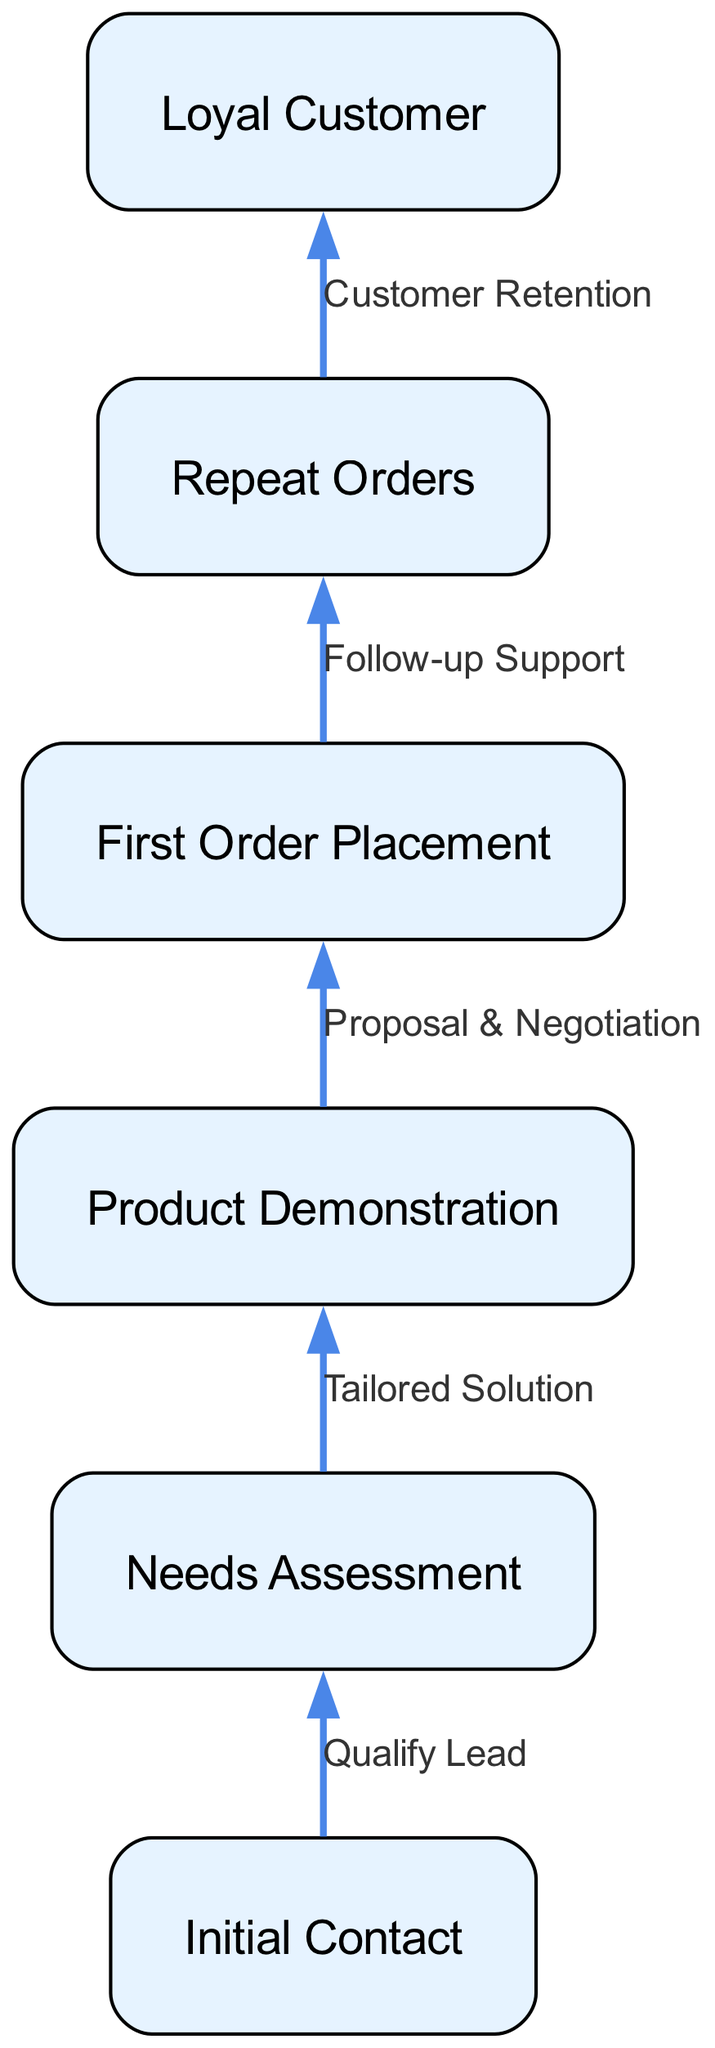What's the total number of nodes in the diagram? The diagram lists a set of nodes: "Loyal Customer," "Repeat Orders," "First Order Placement," "Product Demonstration," "Needs Assessment," and "Initial Contact." Counting these, we find there are six nodes in total.
Answer: 6 What is the last stage in the customer acquisition funnel? In the flow chart, the last stage represented as a node is "Loyal Customer." This is the endpoint of the customer acquisition process, indicating where a customer ideally wants to reach.
Answer: Loyal Customer What is the relationship between "First Order Placement" and "Repeat Orders"? The relationship is indicated by the edge connecting the two nodes. The text on this edge states "Follow-up Support," which describes the action that leads to the transition from "First Order Placement" to "Repeat Orders."
Answer: Follow-up Support Which stage comes after "Needs Assessment"? Following the "Needs Assessment" stage, the next node reached is "Product Demonstration." This indicates the process flow from assessing customer needs to demonstrating the product.
Answer: Product Demonstration How many edges are there in the diagram? The diagram includes connections (edges) that convey the relationships between the nodes. A review of the edges presents five connections in total.
Answer: 5 What action must occur before a "First Order Placement" can happen? According to the diagram, the action that must take place before reaching "First Order Placement" is "Product Demonstration." This step is crucial for proceeding to an actual order.
Answer: Product Demonstration What connects "Initial Contact" to "Needs Assessment"? The edge between "Initial Contact" and "Needs Assessment" is labeled with the text "Qualify Lead," signifying the essential action taken at this point in the funnel.
Answer: Qualify Lead Which node shows the beginning of the flow? The initial node in the flow chart labeled is "Initial Contact," which represents the starting point for engaging potential customers.
Answer: Initial Contact What follows immediately after "Repeat Orders"? The next stage after "Repeat Orders" is "Loyal Customer," indicating the final desired outcome of returning customers following their continued orders.
Answer: Loyal Customer 